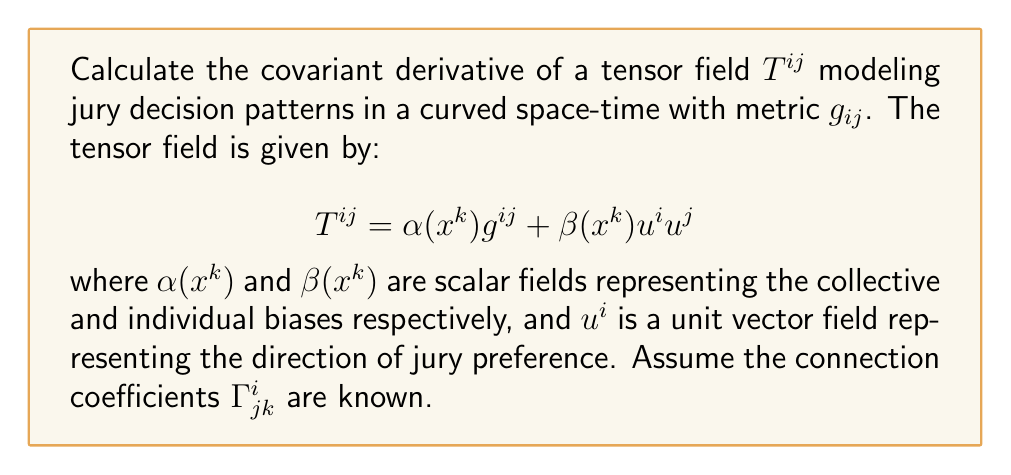What is the answer to this math problem? To calculate the covariant derivative of the tensor field $T^{ij}$, we need to follow these steps:

1) The covariant derivative of a contravariant tensor $T^{ij}$ is given by:

   $$\nabla_k T^{ij} = \partial_k T^{ij} + \Gamma^i_{kl}T^{lj} + \Gamma^j_{kl}T^{il}$$

2) Let's expand $T^{ij}$:
   
   $$\nabla_k (\alpha g^{ij} + \beta u^i u^j)$$

3) Using the linearity of the covariant derivative:

   $$\nabla_k (\alpha g^{ij}) + \nabla_k (\beta u^i u^j)$$

4) For the first term:
   
   $$\nabla_k (\alpha g^{ij}) = (\partial_k \alpha) g^{ij} + \alpha \nabla_k g^{ij}$$
   
   Note that $\nabla_k g^{ij} = 0$ (metric compatibility condition)

5) For the second term:
   
   $$\nabla_k (\beta u^i u^j) = (\partial_k \beta) u^i u^j + \beta (\nabla_k u^i) u^j + \beta u^i (\nabla_k u^j)$$

6) Expanding $\nabla_k u^i$:

   $$\nabla_k u^i = \partial_k u^i + \Gamma^i_{kl}u^l$$

7) Combining all terms:

   $$\nabla_k T^{ij} = (\partial_k \alpha) g^{ij} + (\partial_k \beta) u^i u^j + \beta (\partial_k u^i + \Gamma^i_{kl}u^l) u^j + \beta u^i (\partial_k u^j + \Gamma^j_{kl}u^l)$$

This is the covariant derivative of the tensor field $T^{ij}$.
Answer: $$\nabla_k T^{ij} = (\partial_k \alpha) g^{ij} + (\partial_k \beta) u^i u^j + \beta (\partial_k u^i + \Gamma^i_{kl}u^l) u^j + \beta u^i (\partial_k u^j + \Gamma^j_{kl}u^l)$$ 